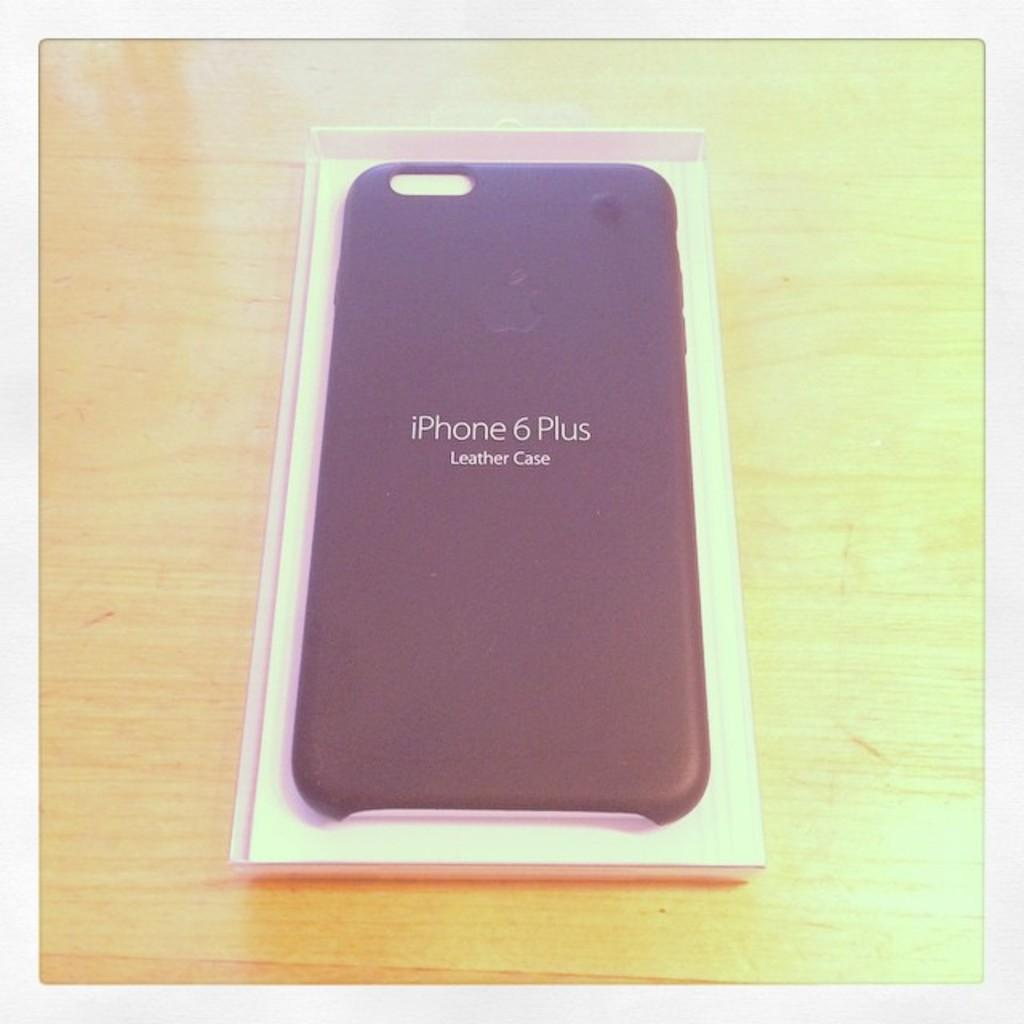<image>
Give a short and clear explanation of the subsequent image. A leather phone case for an iPhone 6 Plus. 